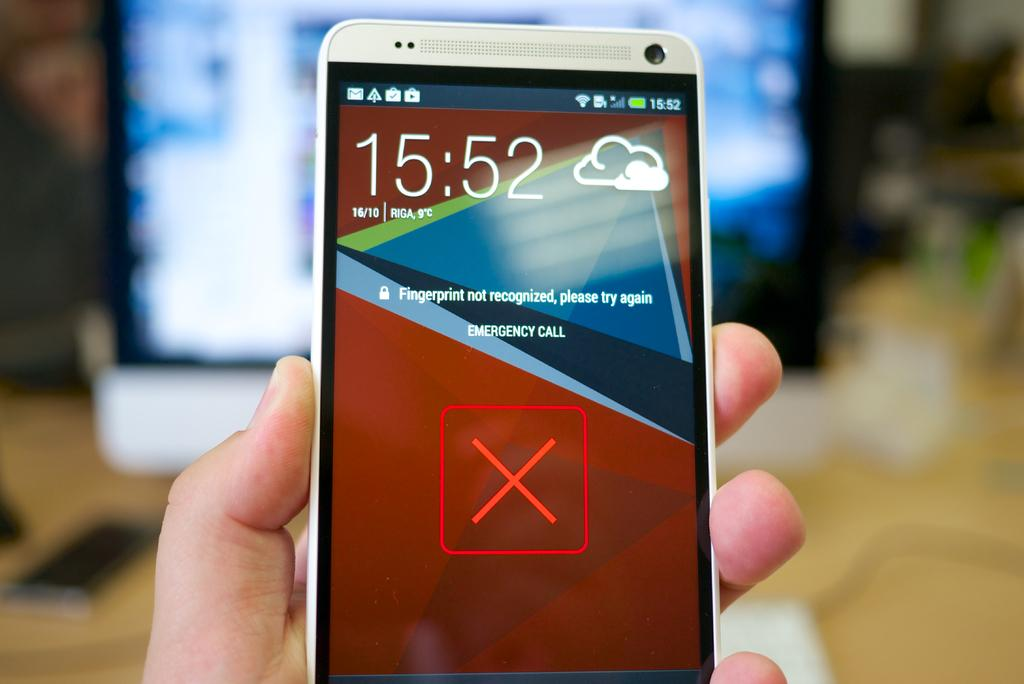<image>
Summarize the visual content of the image. A phone display shows the current time is 15:52pm and the weather at 9 degrees celsious in Riga 